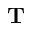Convert formula to latex. <formula><loc_0><loc_0><loc_500><loc_500>\mathbf T</formula> 